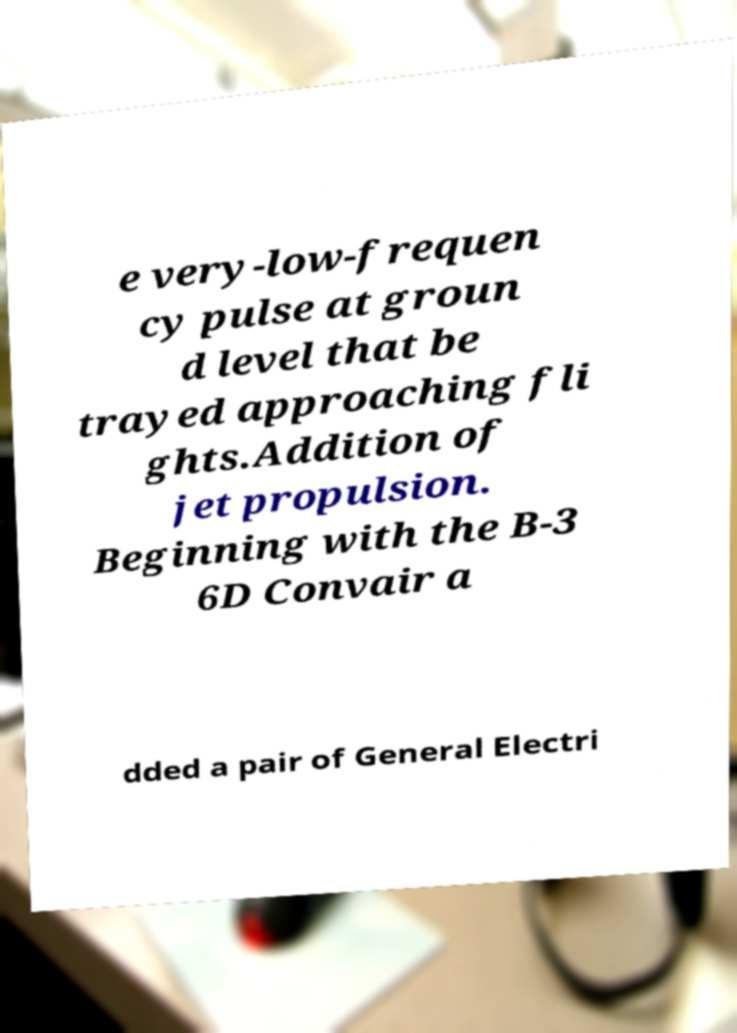Could you assist in decoding the text presented in this image and type it out clearly? e very-low-frequen cy pulse at groun d level that be trayed approaching fli ghts.Addition of jet propulsion. Beginning with the B-3 6D Convair a dded a pair of General Electri 